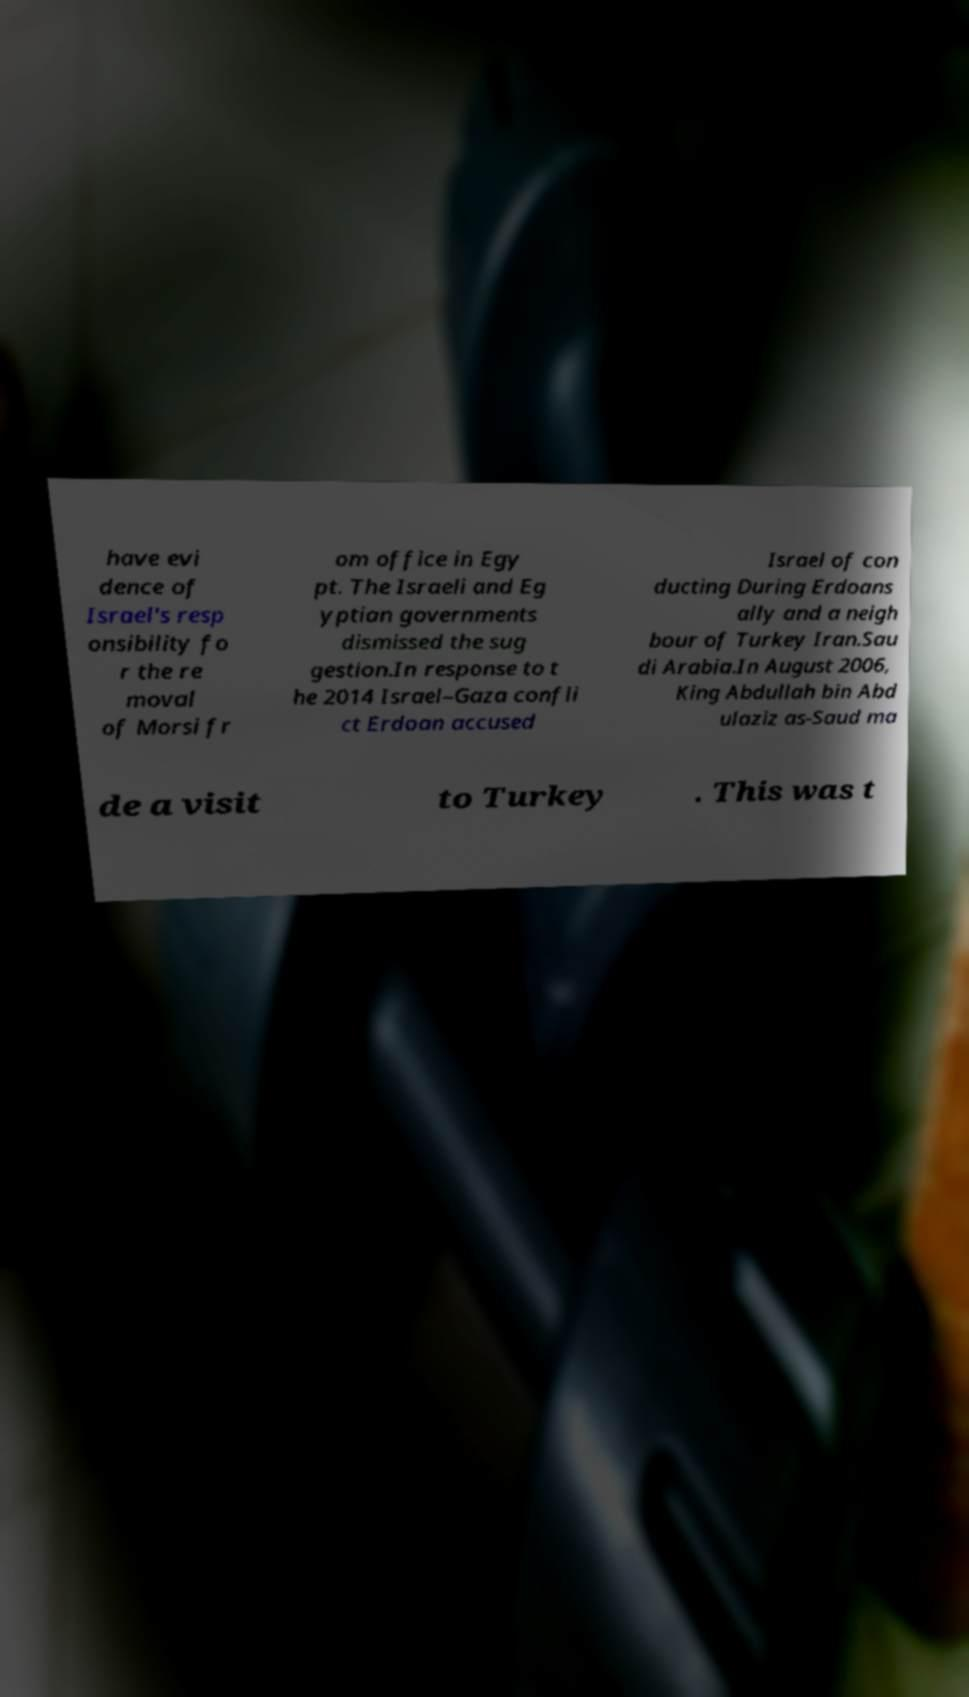For documentation purposes, I need the text within this image transcribed. Could you provide that? have evi dence of Israel's resp onsibility fo r the re moval of Morsi fr om office in Egy pt. The Israeli and Eg yptian governments dismissed the sug gestion.In response to t he 2014 Israel–Gaza confli ct Erdoan accused Israel of con ducting During Erdoans ally and a neigh bour of Turkey Iran.Sau di Arabia.In August 2006, King Abdullah bin Abd ulaziz as-Saud ma de a visit to Turkey . This was t 